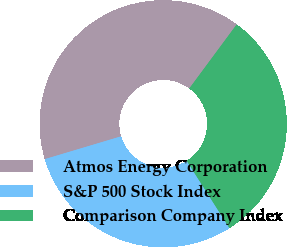Convert chart to OTSL. <chart><loc_0><loc_0><loc_500><loc_500><pie_chart><fcel>Atmos Energy Corporation<fcel>S&P 500 Stock Index<fcel>Comparison Company Index<nl><fcel>39.76%<fcel>29.38%<fcel>30.86%<nl></chart> 